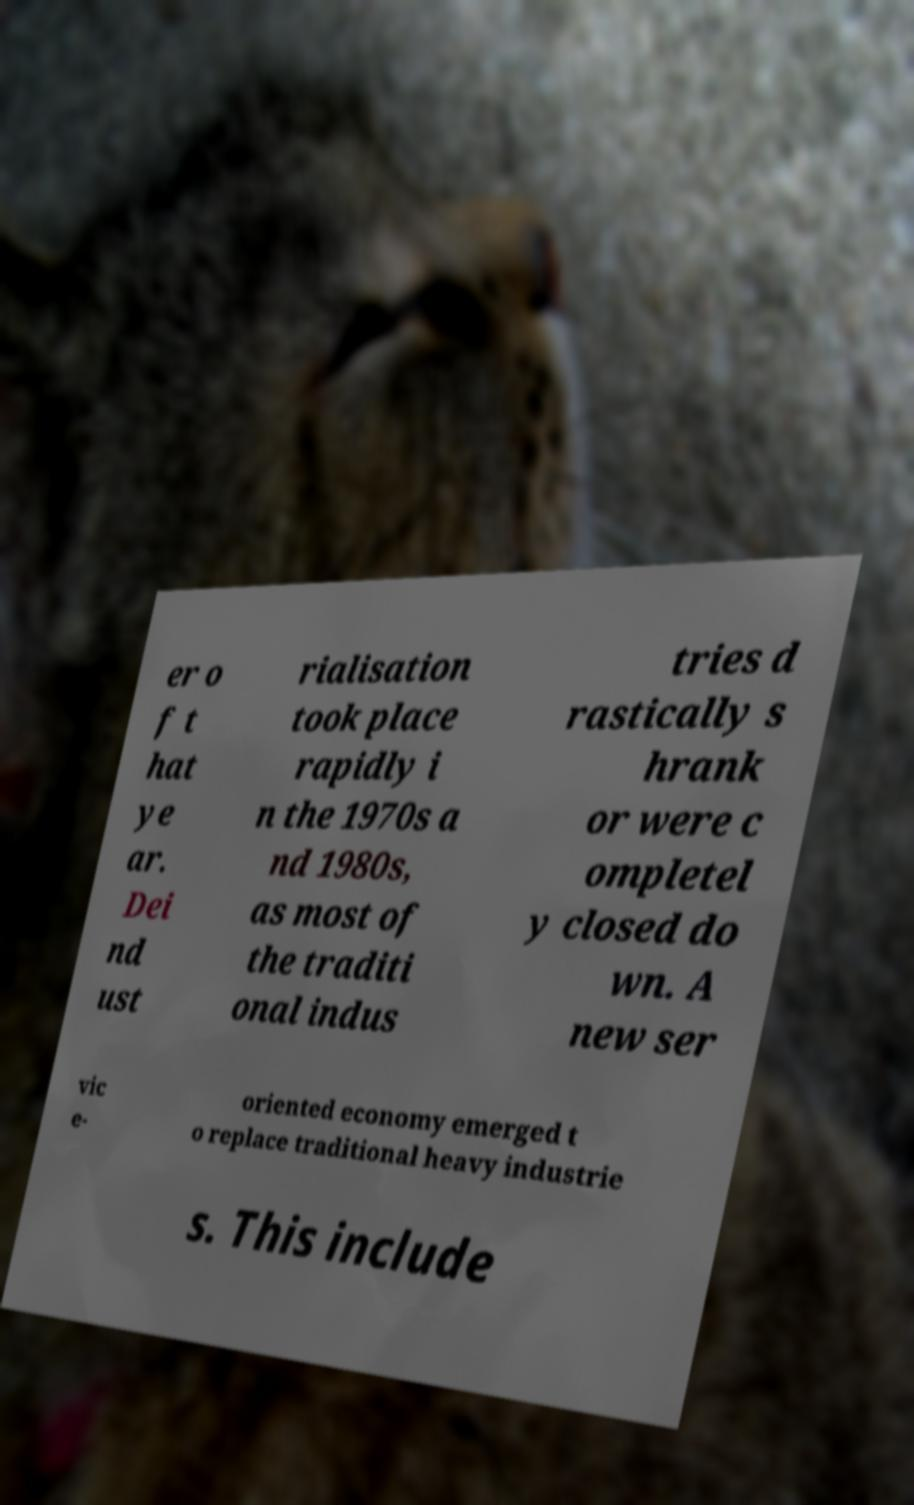I need the written content from this picture converted into text. Can you do that? er o f t hat ye ar. Dei nd ust rialisation took place rapidly i n the 1970s a nd 1980s, as most of the traditi onal indus tries d rastically s hrank or were c ompletel y closed do wn. A new ser vic e- oriented economy emerged t o replace traditional heavy industrie s. This include 